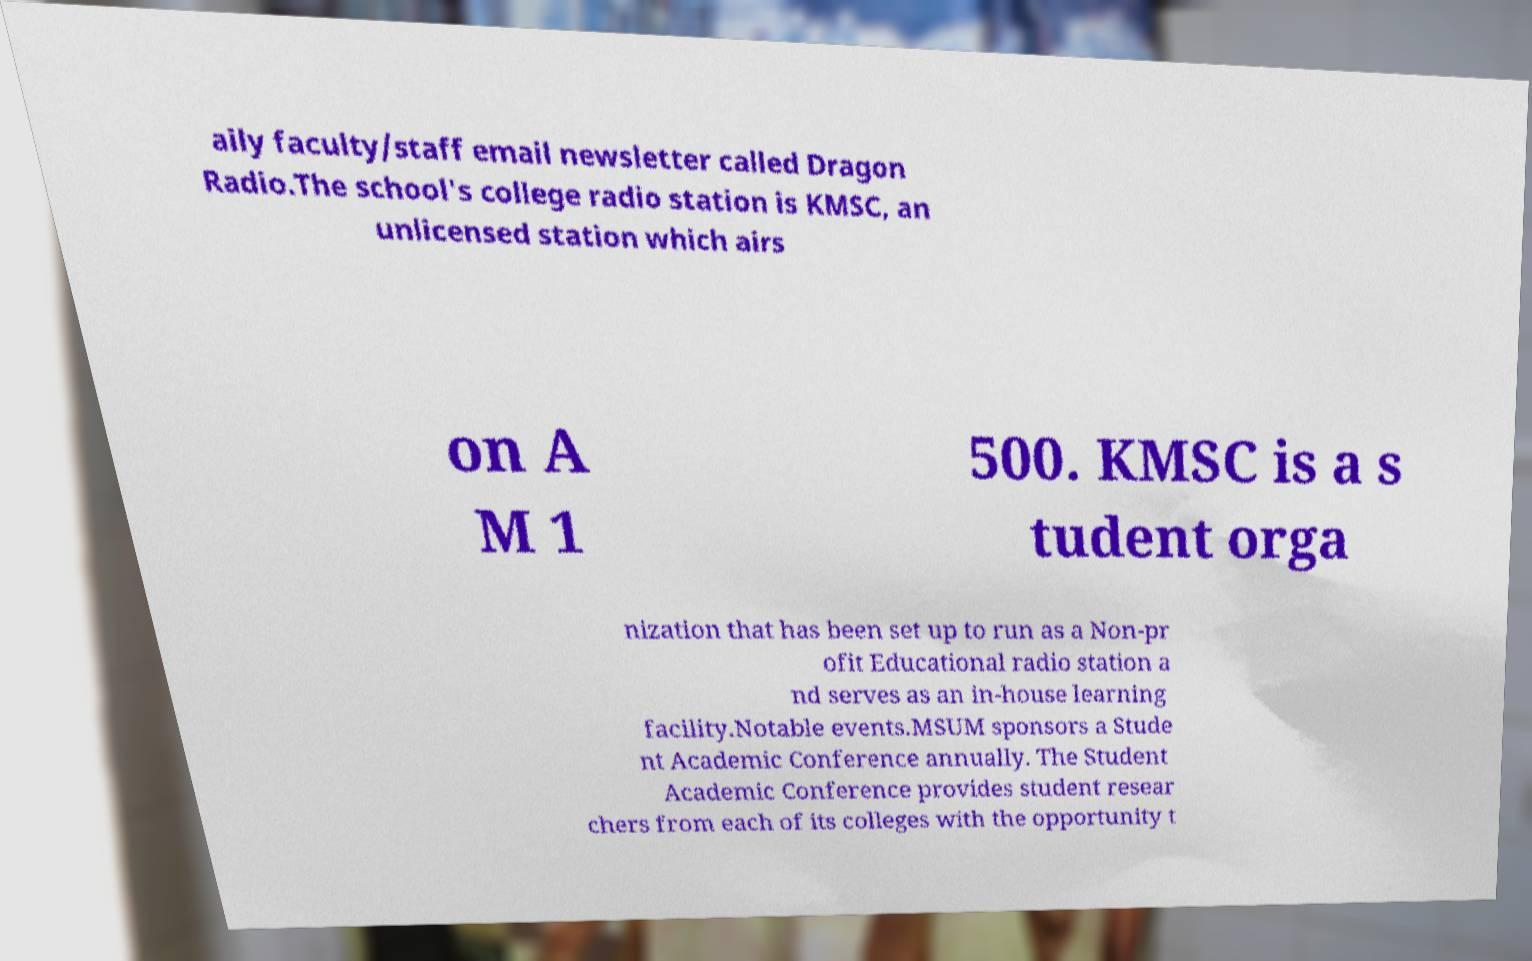What messages or text are displayed in this image? I need them in a readable, typed format. aily faculty/staff email newsletter called Dragon Radio.The school's college radio station is KMSC, an unlicensed station which airs on A M 1 500. KMSC is a s tudent orga nization that has been set up to run as a Non-pr ofit Educational radio station a nd serves as an in-house learning facility.Notable events.MSUM sponsors a Stude nt Academic Conference annually. The Student Academic Conference provides student resear chers from each of its colleges with the opportunity t 